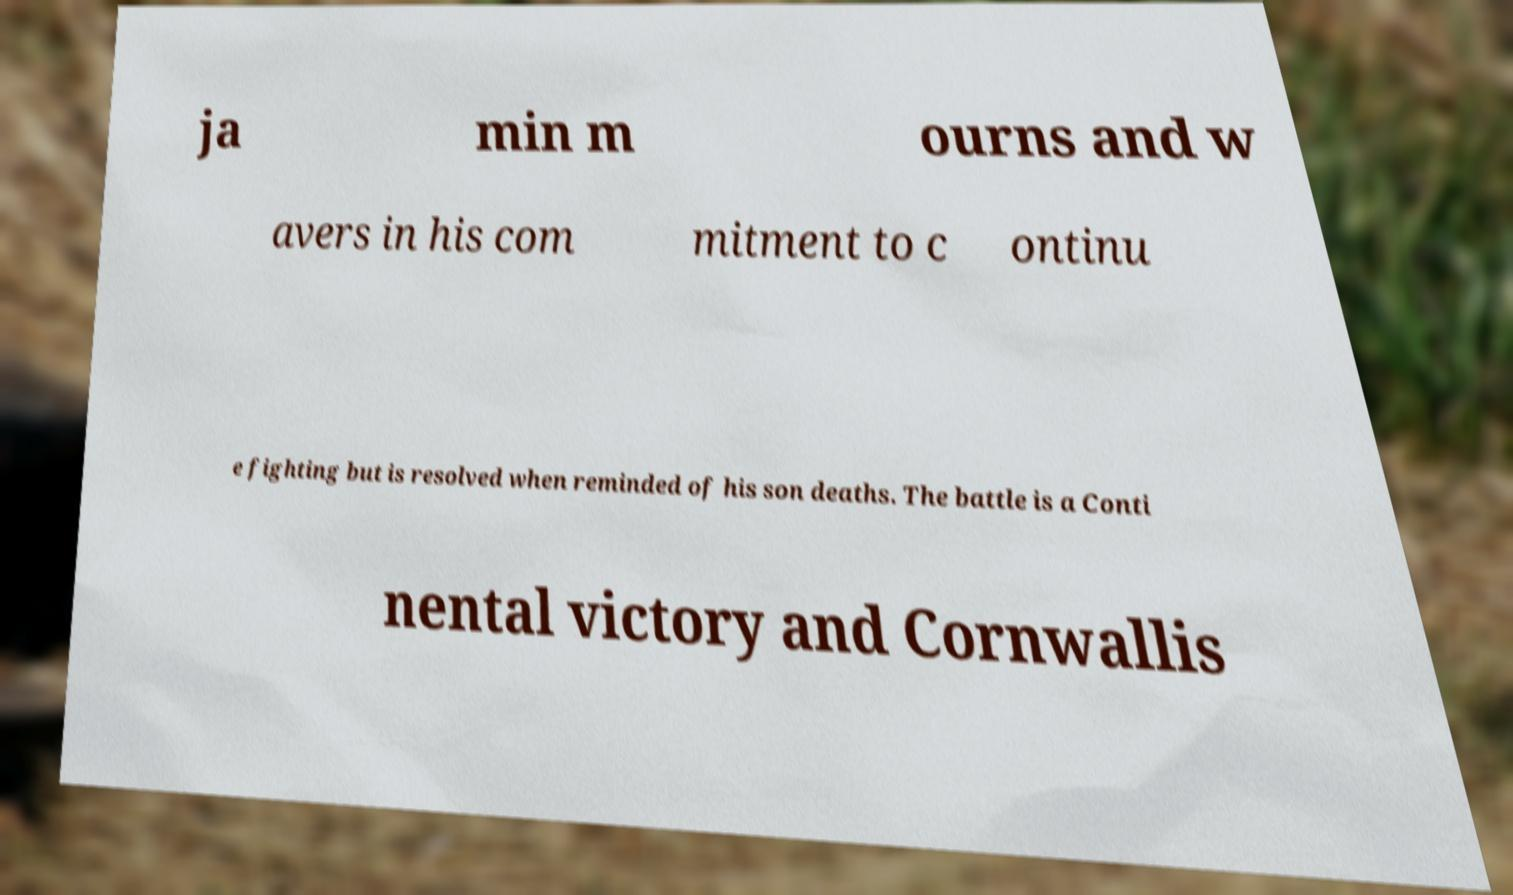I need the written content from this picture converted into text. Can you do that? ja min m ourns and w avers in his com mitment to c ontinu e fighting but is resolved when reminded of his son deaths. The battle is a Conti nental victory and Cornwallis 